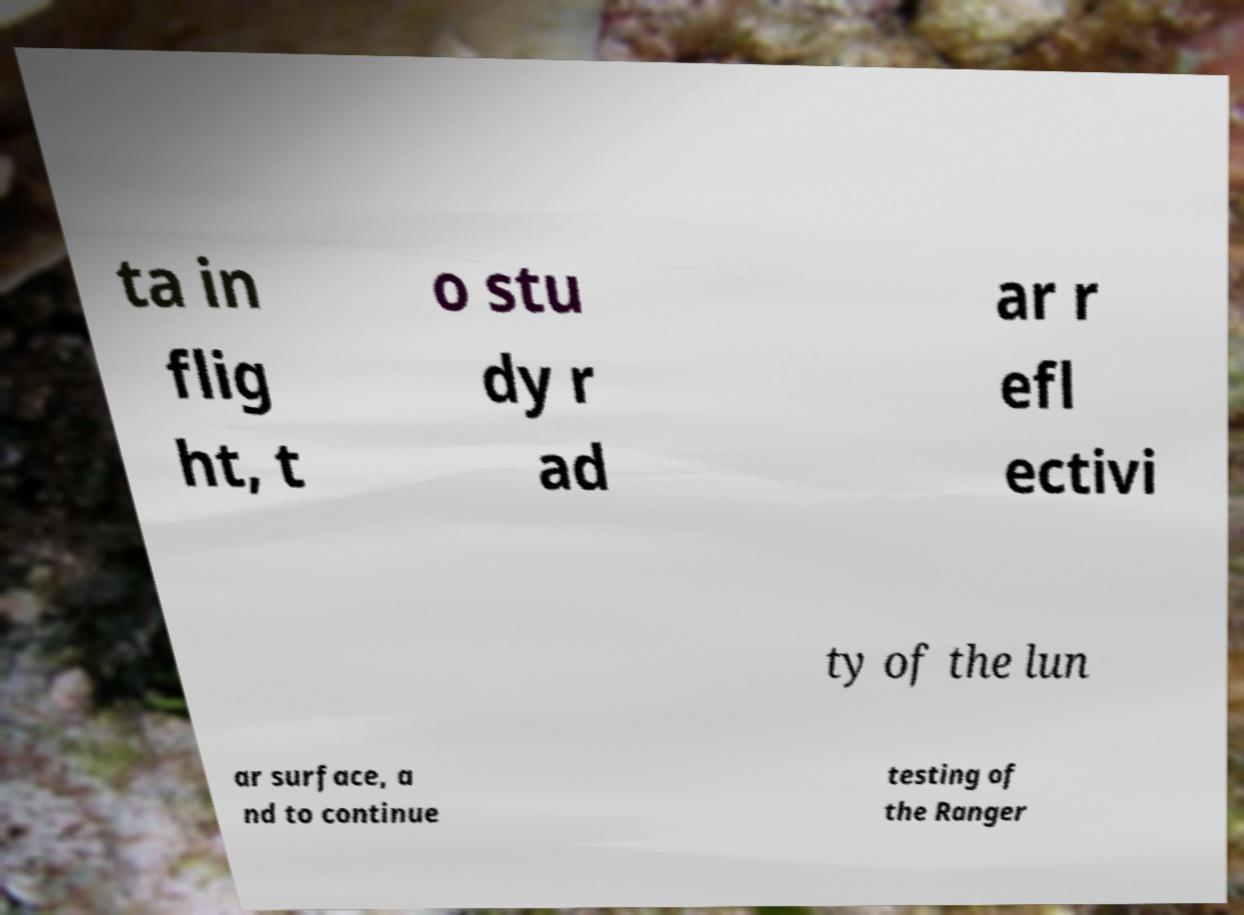Can you read and provide the text displayed in the image?This photo seems to have some interesting text. Can you extract and type it out for me? ta in flig ht, t o stu dy r ad ar r efl ectivi ty of the lun ar surface, a nd to continue testing of the Ranger 